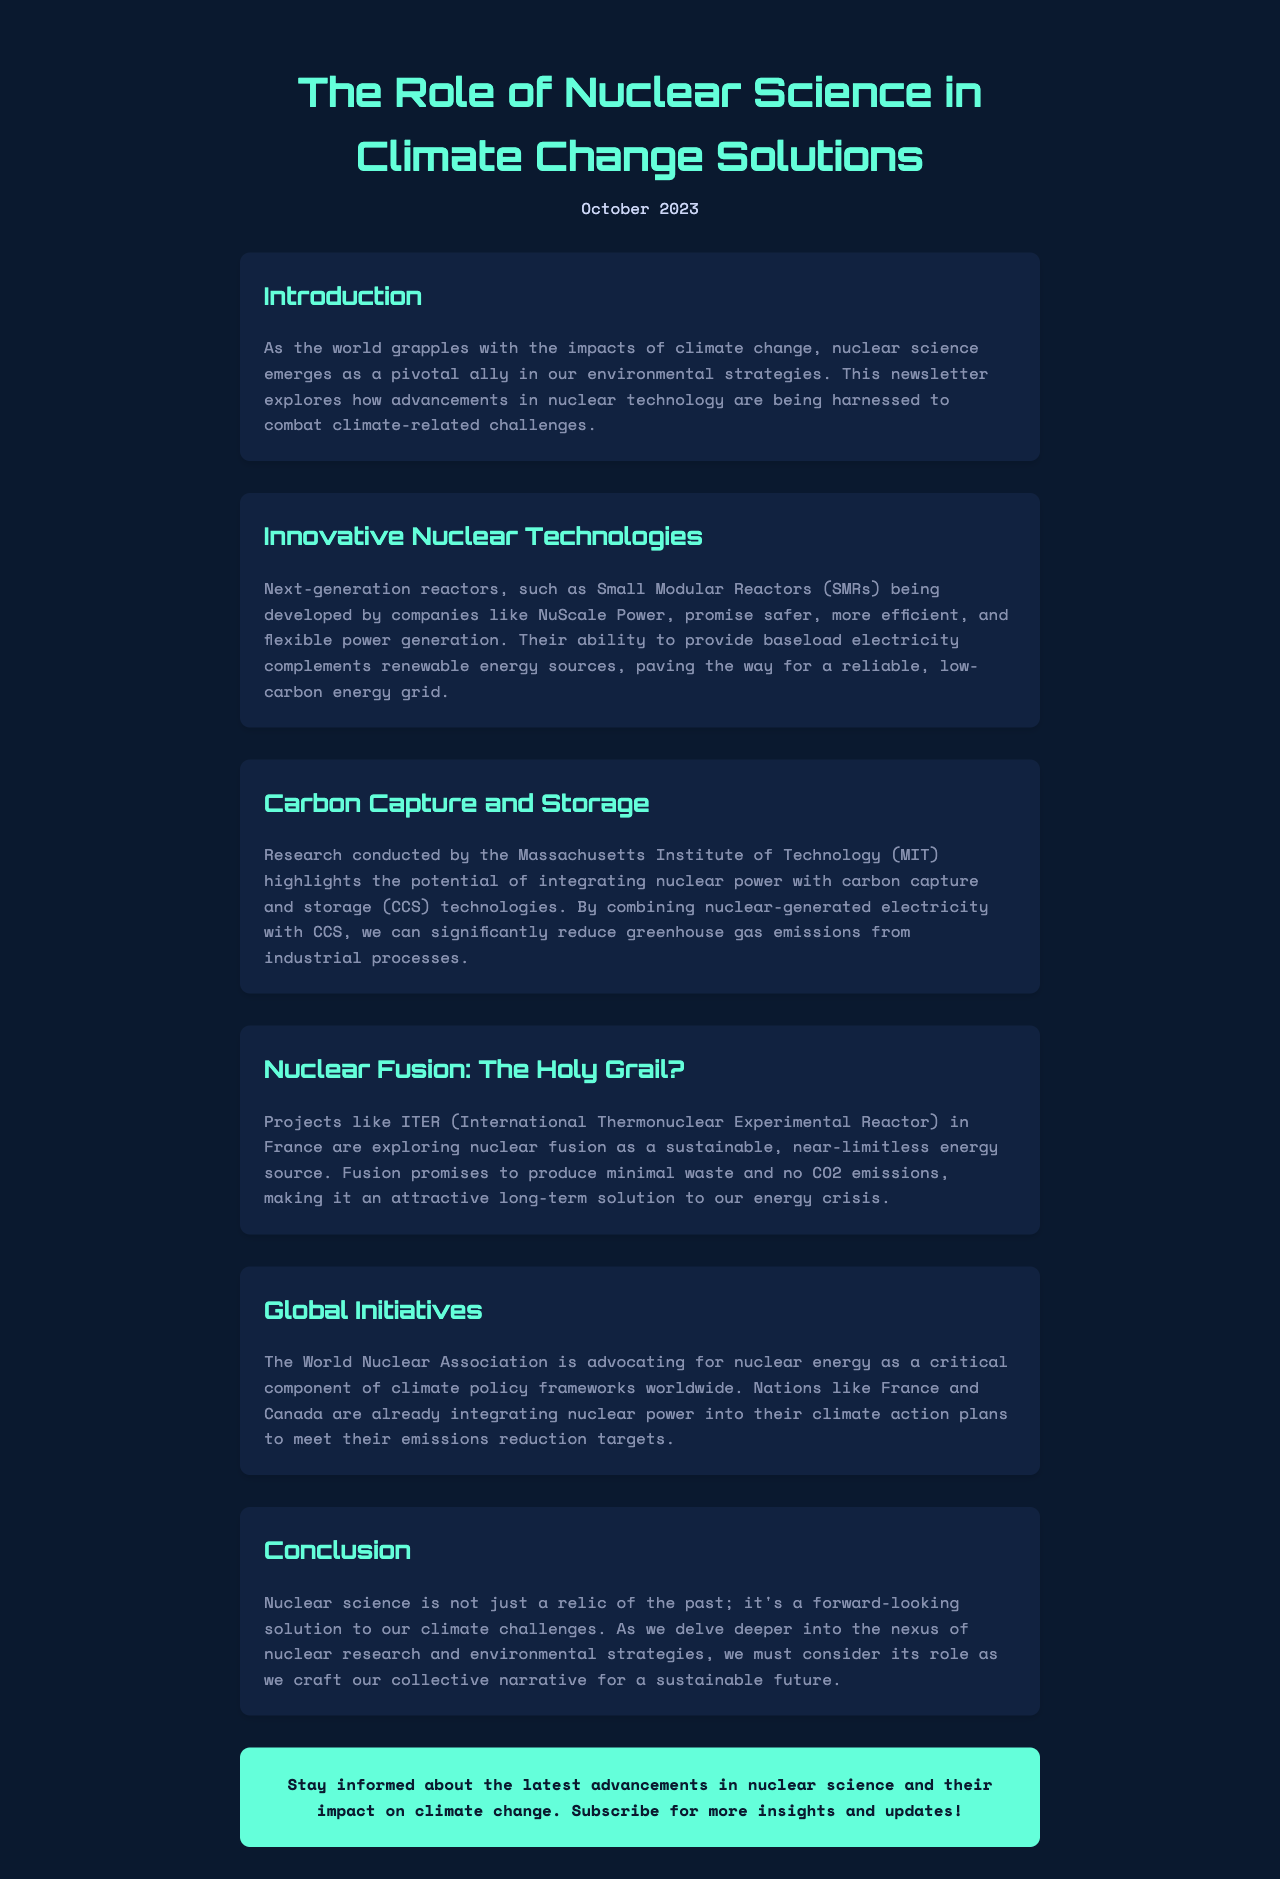What is the title of the newsletter? The title of the newsletter is provided in the header section of the document.
Answer: The Role of Nuclear Science in Climate Change Solutions What month and year was this newsletter published? The publication date is noted right under the title in the header.
Answer: October 2023 What does SMR stand for according to the document? The abbreviation SMR is defined in the context of the section discussing innovative nuclear technologies.
Answer: Small Modular Reactors Which institution conducted research on integrating nuclear power with CCS? The institution mentioned in the carbon capture and storage section is responsible for the research outlined.
Answer: Massachusetts Institute of Technology What is ITER exploring as a potential energy source? The document discusses what the ITER project is focusing on, particularly in relation to energy.
Answer: Nuclear fusion Which country is mentioned as actively integrating nuclear power into its climate action plans? The global initiatives section highlights nations that are adopting nuclear energy strategies in climate policies.
Answer: France What is the purpose of the CTA (Call to Action) at the end of the newsletter? The CTA encourages readers to take a specific action following the information presented in the newsletter.
Answer: Stay informed about the latest advancements in nuclear science What role does nuclear science play in the context of climate change, based on the conclusion? The conclusion summarizes the overarching theme about the importance of nuclear science in addressing environmental challenges.
Answer: A forward-looking solution to our climate challenges 